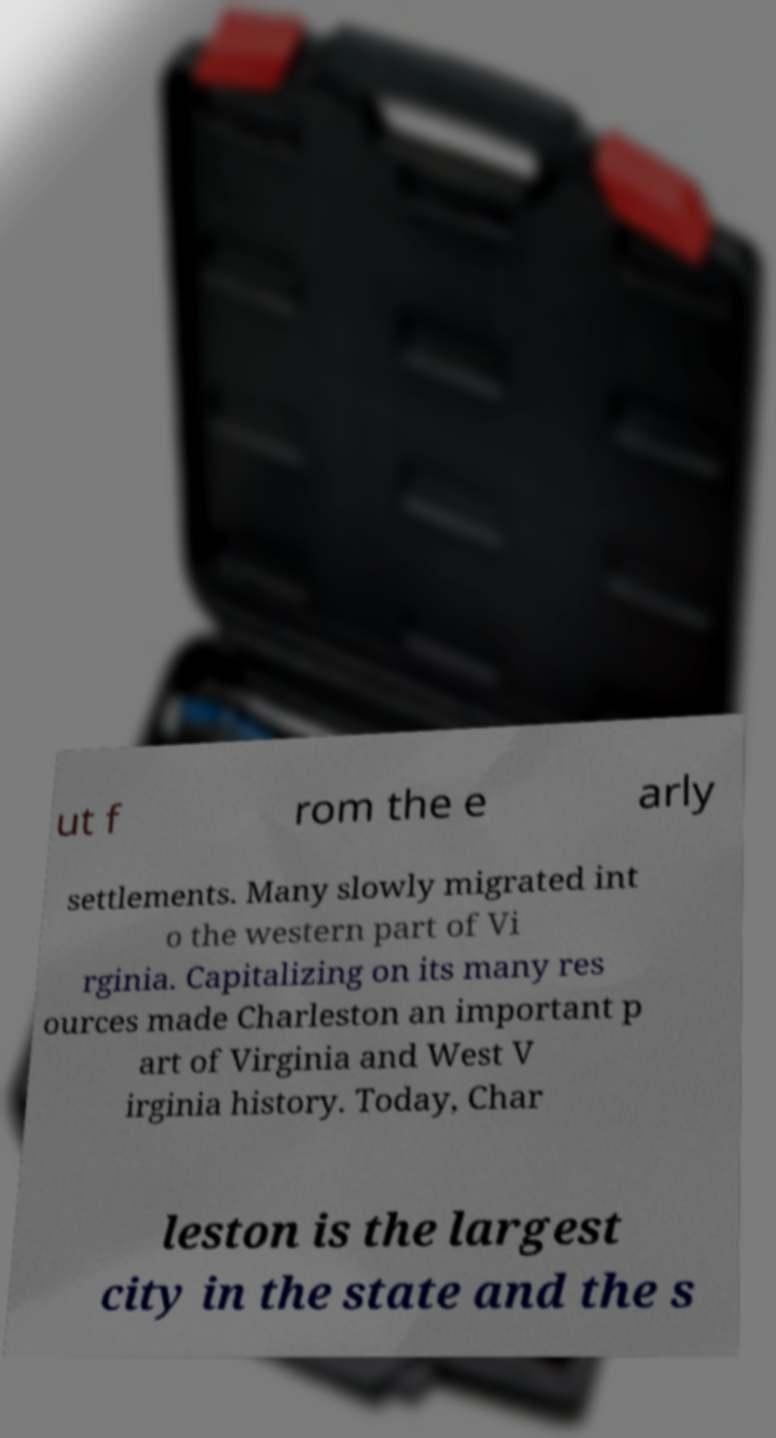Could you assist in decoding the text presented in this image and type it out clearly? ut f rom the e arly settlements. Many slowly migrated int o the western part of Vi rginia. Capitalizing on its many res ources made Charleston an important p art of Virginia and West V irginia history. Today, Char leston is the largest city in the state and the s 